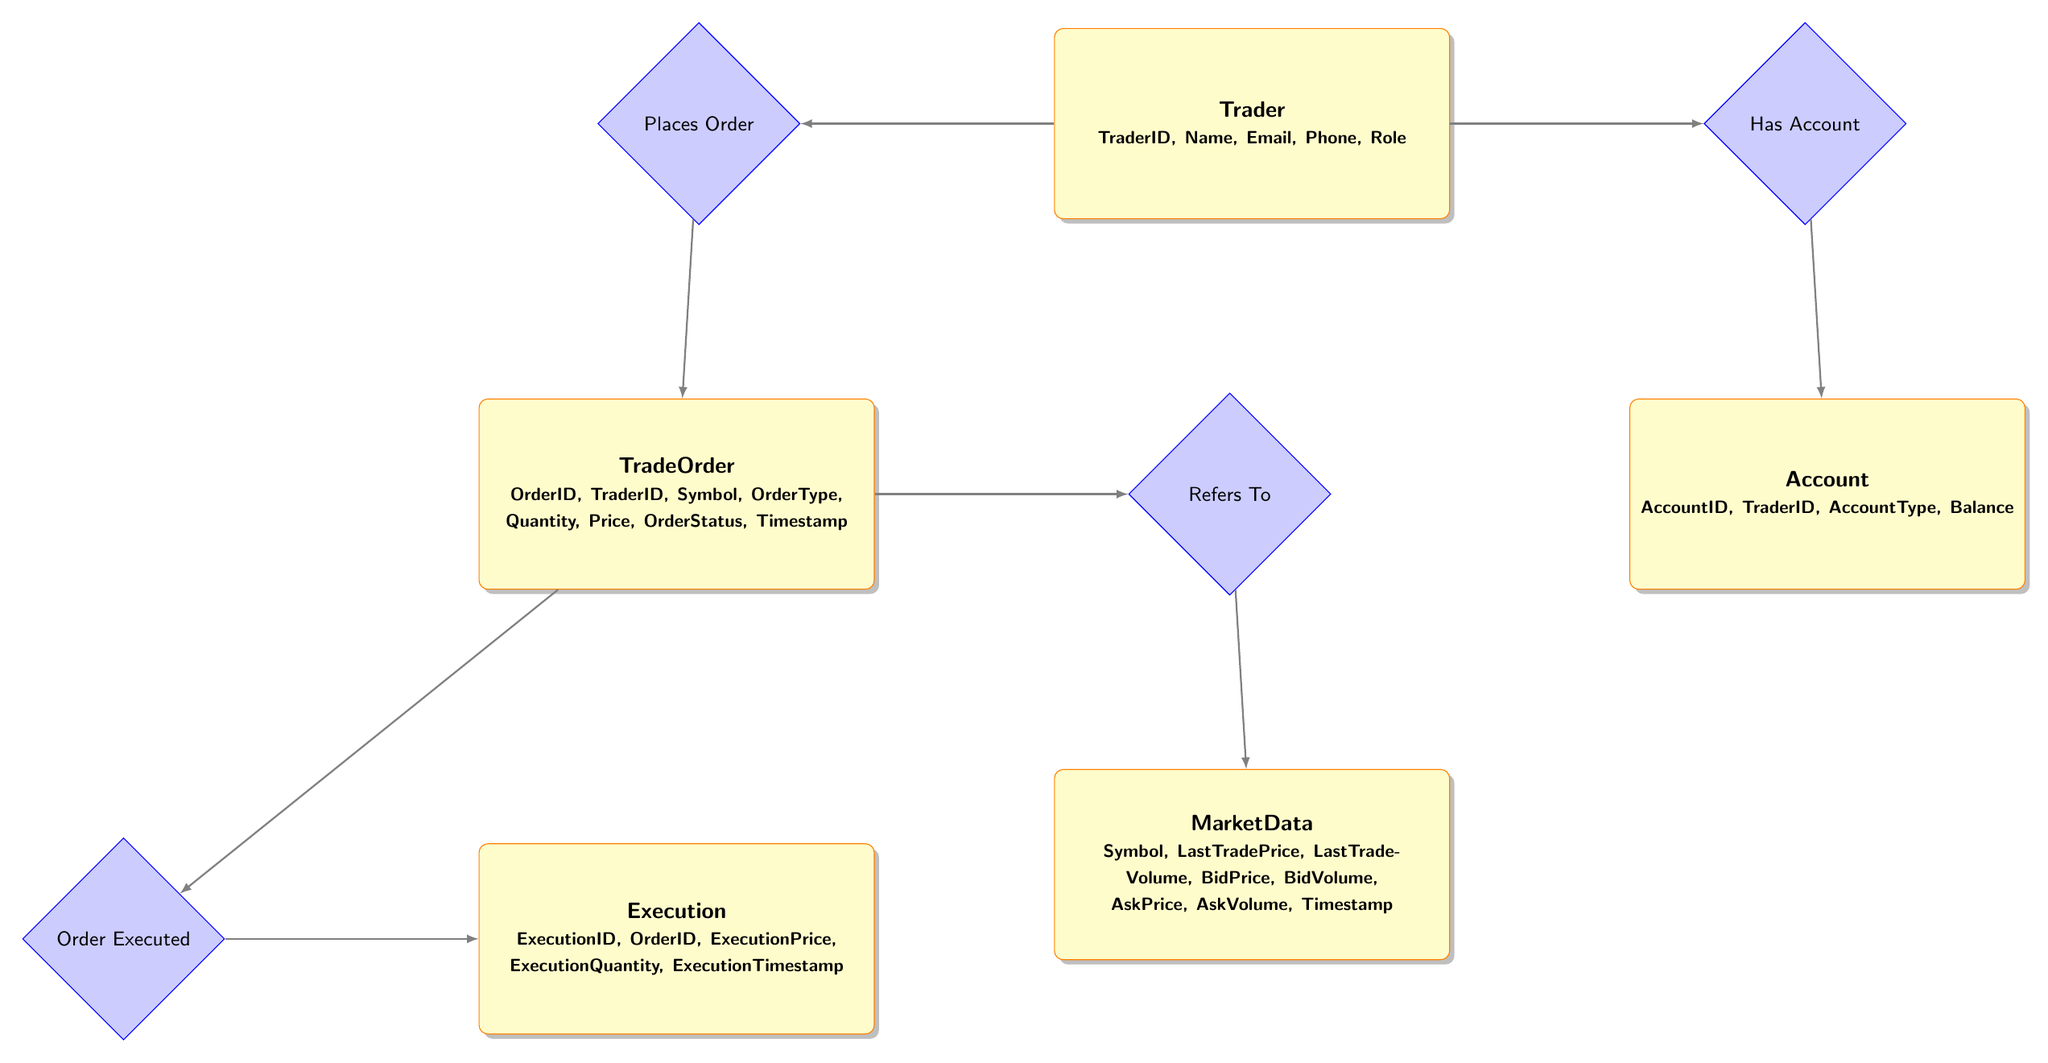What is the primary entity in this diagram? The primary entity represents the main actor in the system, which is the Trader. This can be identified as it is drawn as a rectangle and contains the most attributes related to individual users of the system.
Answer: Trader How many entities are present in the diagram? Counting all the rectangles in the diagram, there are five distinct entities: Trader, Account, TradeOrder, Execution, and MarketData.
Answer: Five What is the relationship between Trader and TradeOrder? The relationship indicates that a Trader can place an Order, which is represented by the diamond "Places Order" connecting these two entities.
Answer: Places Order Which entity holds the status of the order? The TradeOrder entity includes the attribute 'OrderStatus' that indicates the status of each order placed by the trader.
Answer: TradeOrder How many relationships are associated with the TradeOrder entity? The TradeOrder entity has two relationships: it is connected to both Execution (Order Executed) and MarketData (Refers To), totaling two relationships.
Answer: Two What does the Execution entity track in its attributes? The Execution entity tracks details about the actual execution of the trade, specifically 'ExecutionPrice', 'ExecutionQuantity', and 'ExecutionTimestamp', among others.
Answer: Execution details Which entity's attribute includes the trader's balance? The Account entity includes the attribute 'Balance', which represents the amount available in a trader's account.
Answer: Account What kind of relationship exists between TradeOrder and MarketData? The diagram specifies the relationship 'Refers To', indicating that a TradeOrder makes reference to MarketData to retrieve price and volume information.
Answer: Refers To Explain how a trader executes a trade based on the diagram. A Trader first places a TradeOrder for a specific symbol. Once the order is executed according to the market conditions, an Execution record is created that contains the execution details. Thus, the process flows from Trader to TradeOrder, then to Execution.
Answer: Trader -> TradeOrder -> Execution 